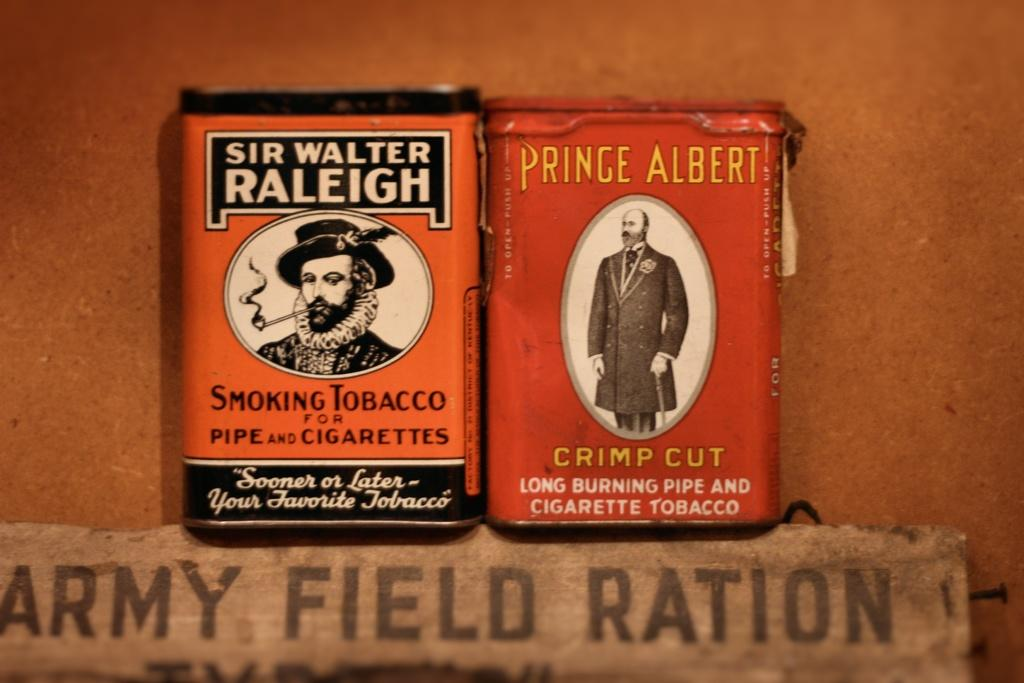<image>
Share a concise interpretation of the image provided. Sir Walter Raleigh cigarettes placed next to a Prince Albert box of cigarettes. 